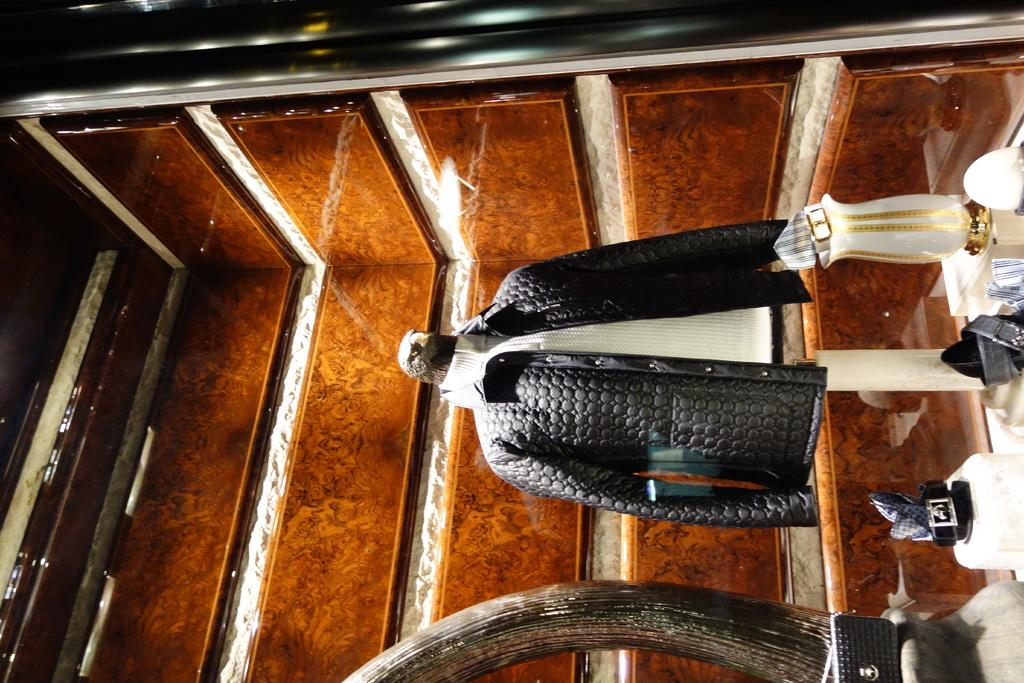What type of clothing item is present in the image? There is a jacket in the image. What other accessory can be seen in the image? There are belts in the image. What type of tray is used to hold the belts in the image? There is no tray present in the image; the belts are not being held or displayed on a tray. 